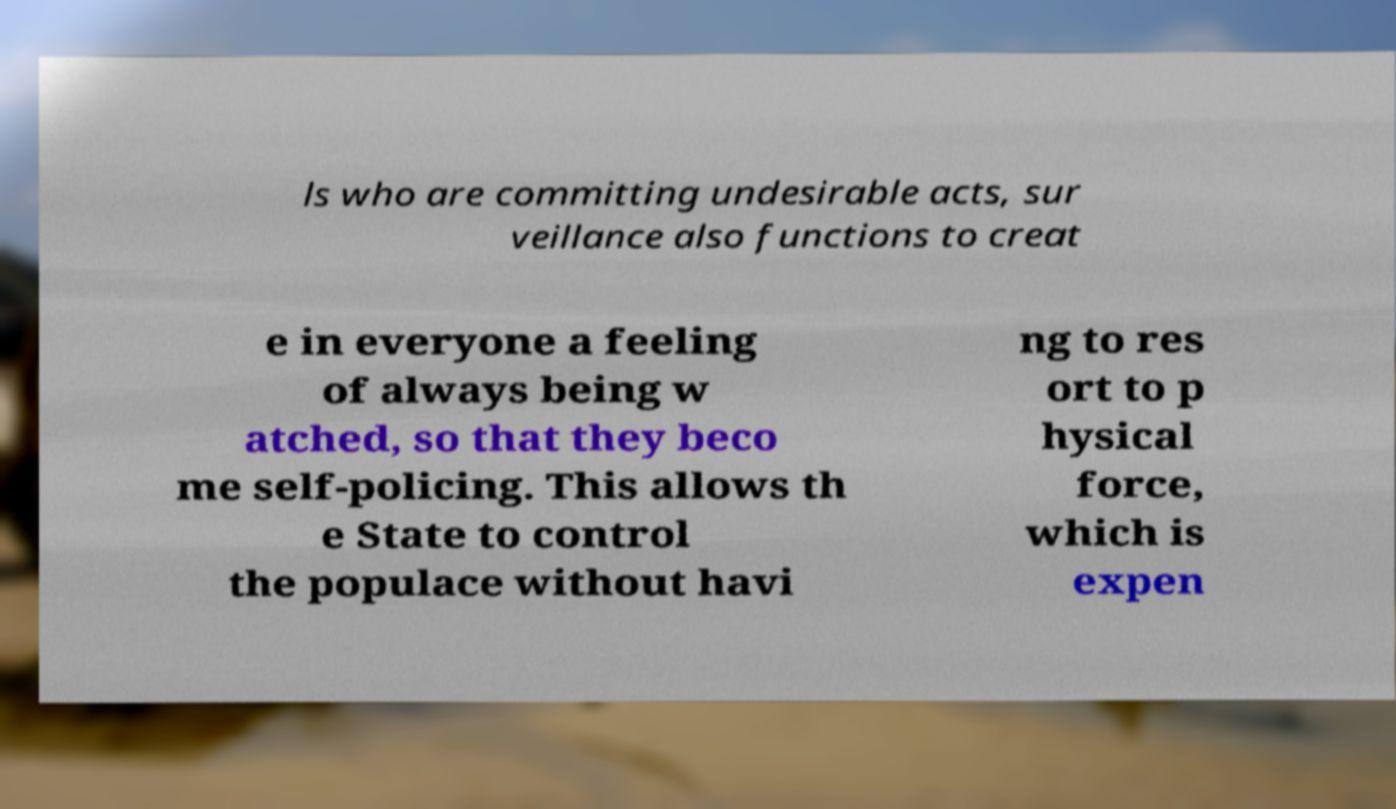Could you extract and type out the text from this image? ls who are committing undesirable acts, sur veillance also functions to creat e in everyone a feeling of always being w atched, so that they beco me self-policing. This allows th e State to control the populace without havi ng to res ort to p hysical force, which is expen 